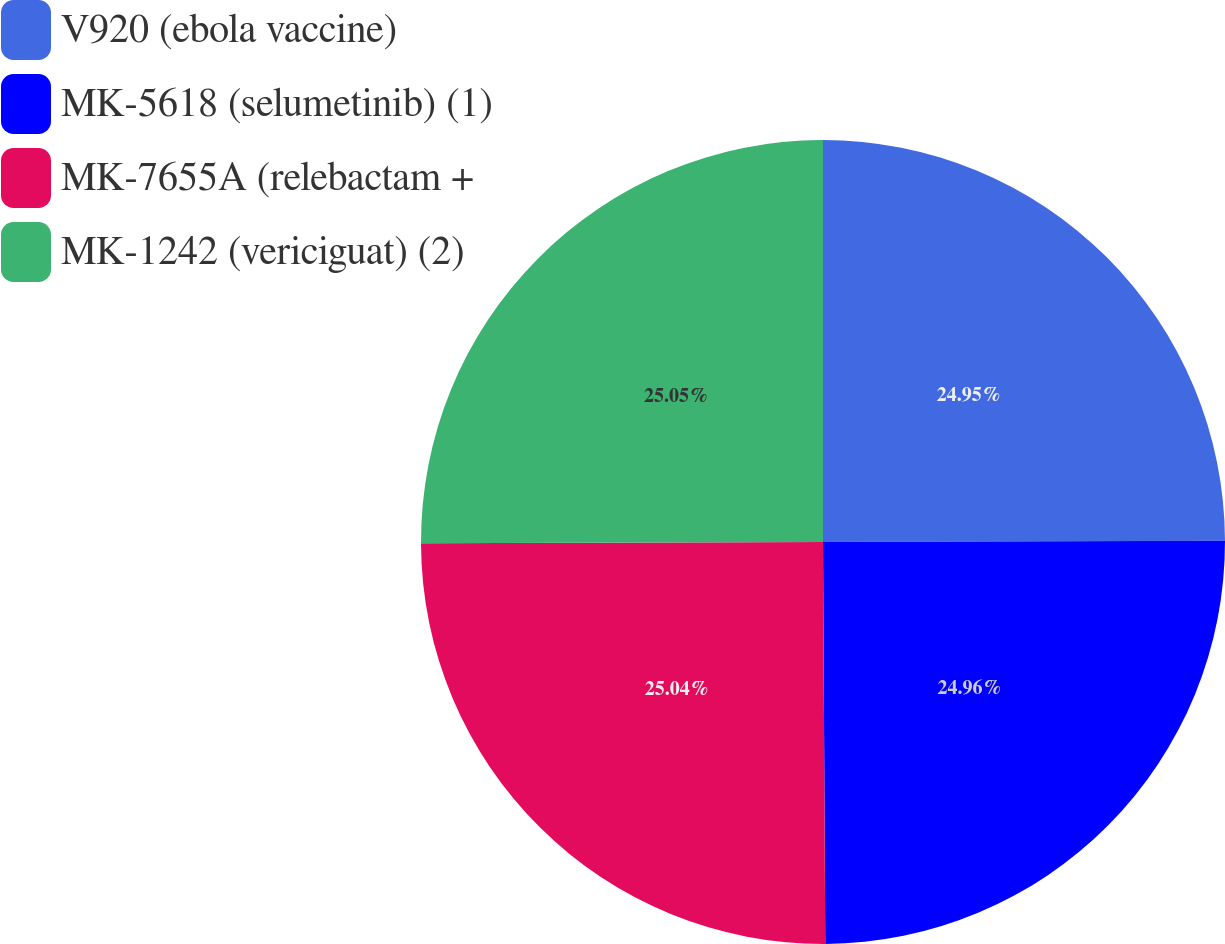<chart> <loc_0><loc_0><loc_500><loc_500><pie_chart><fcel>V920 (ebola vaccine)<fcel>MK-5618 (selumetinib) (1)<fcel>MK-7655A (relebactam +<fcel>MK-1242 (vericiguat) (2)<nl><fcel>24.95%<fcel>24.96%<fcel>25.04%<fcel>25.05%<nl></chart> 